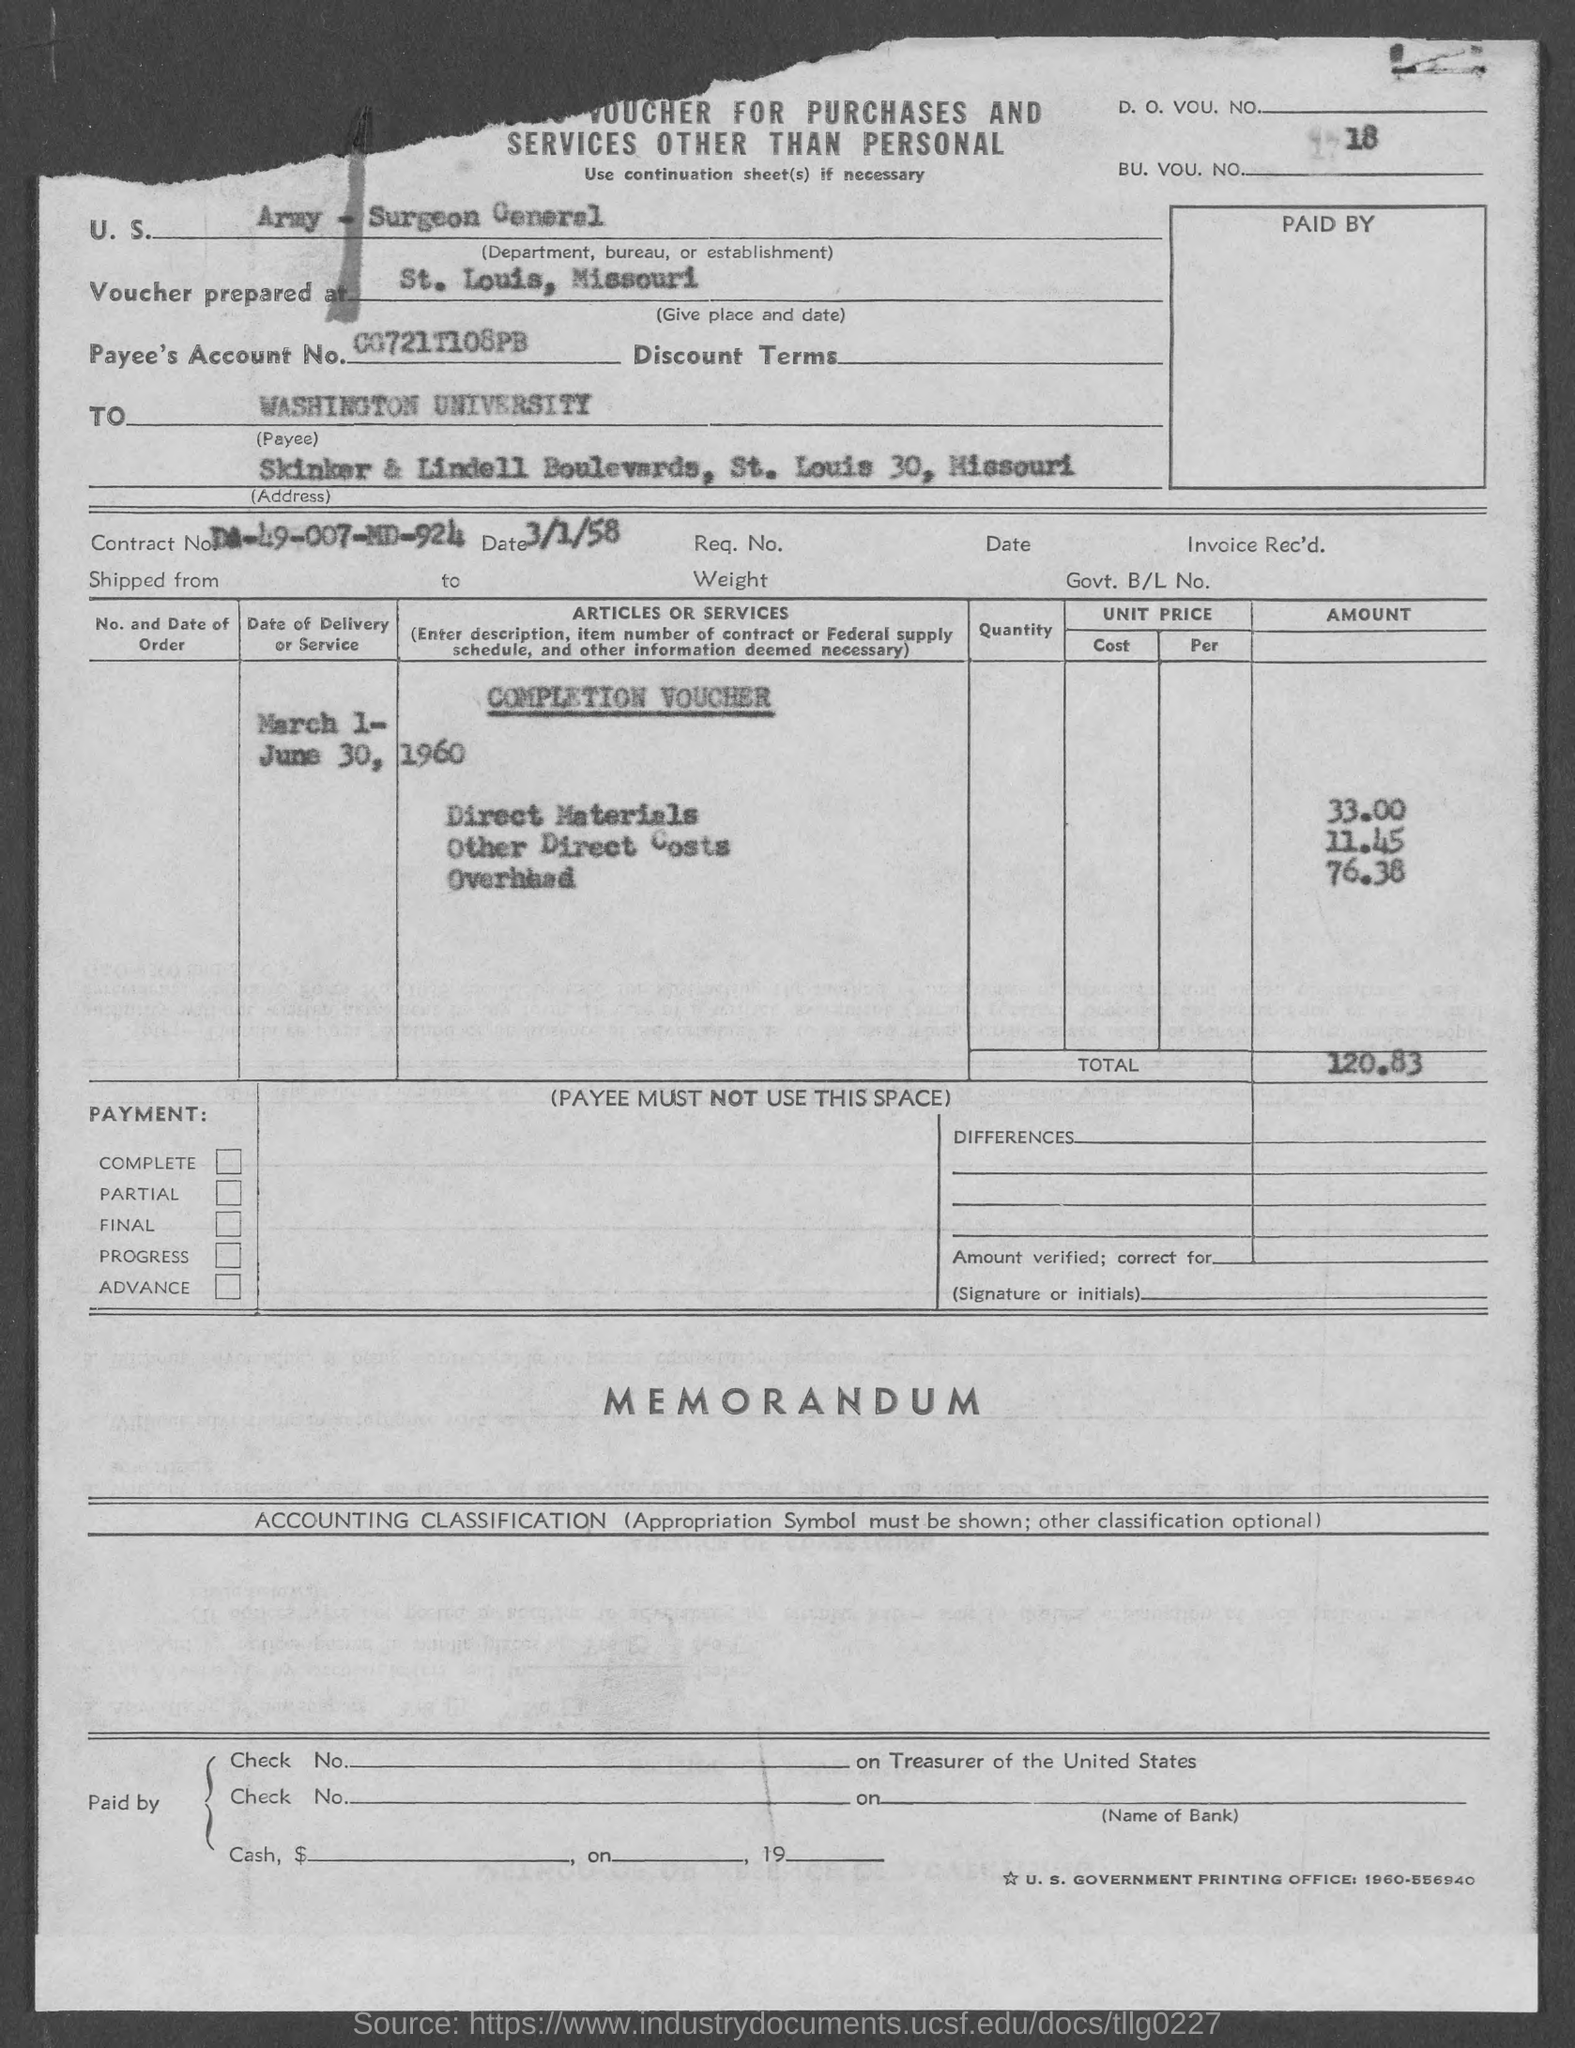Specify some key components in this picture. The payee's account number is 00721T108PB.. What is the BU number? 18? 